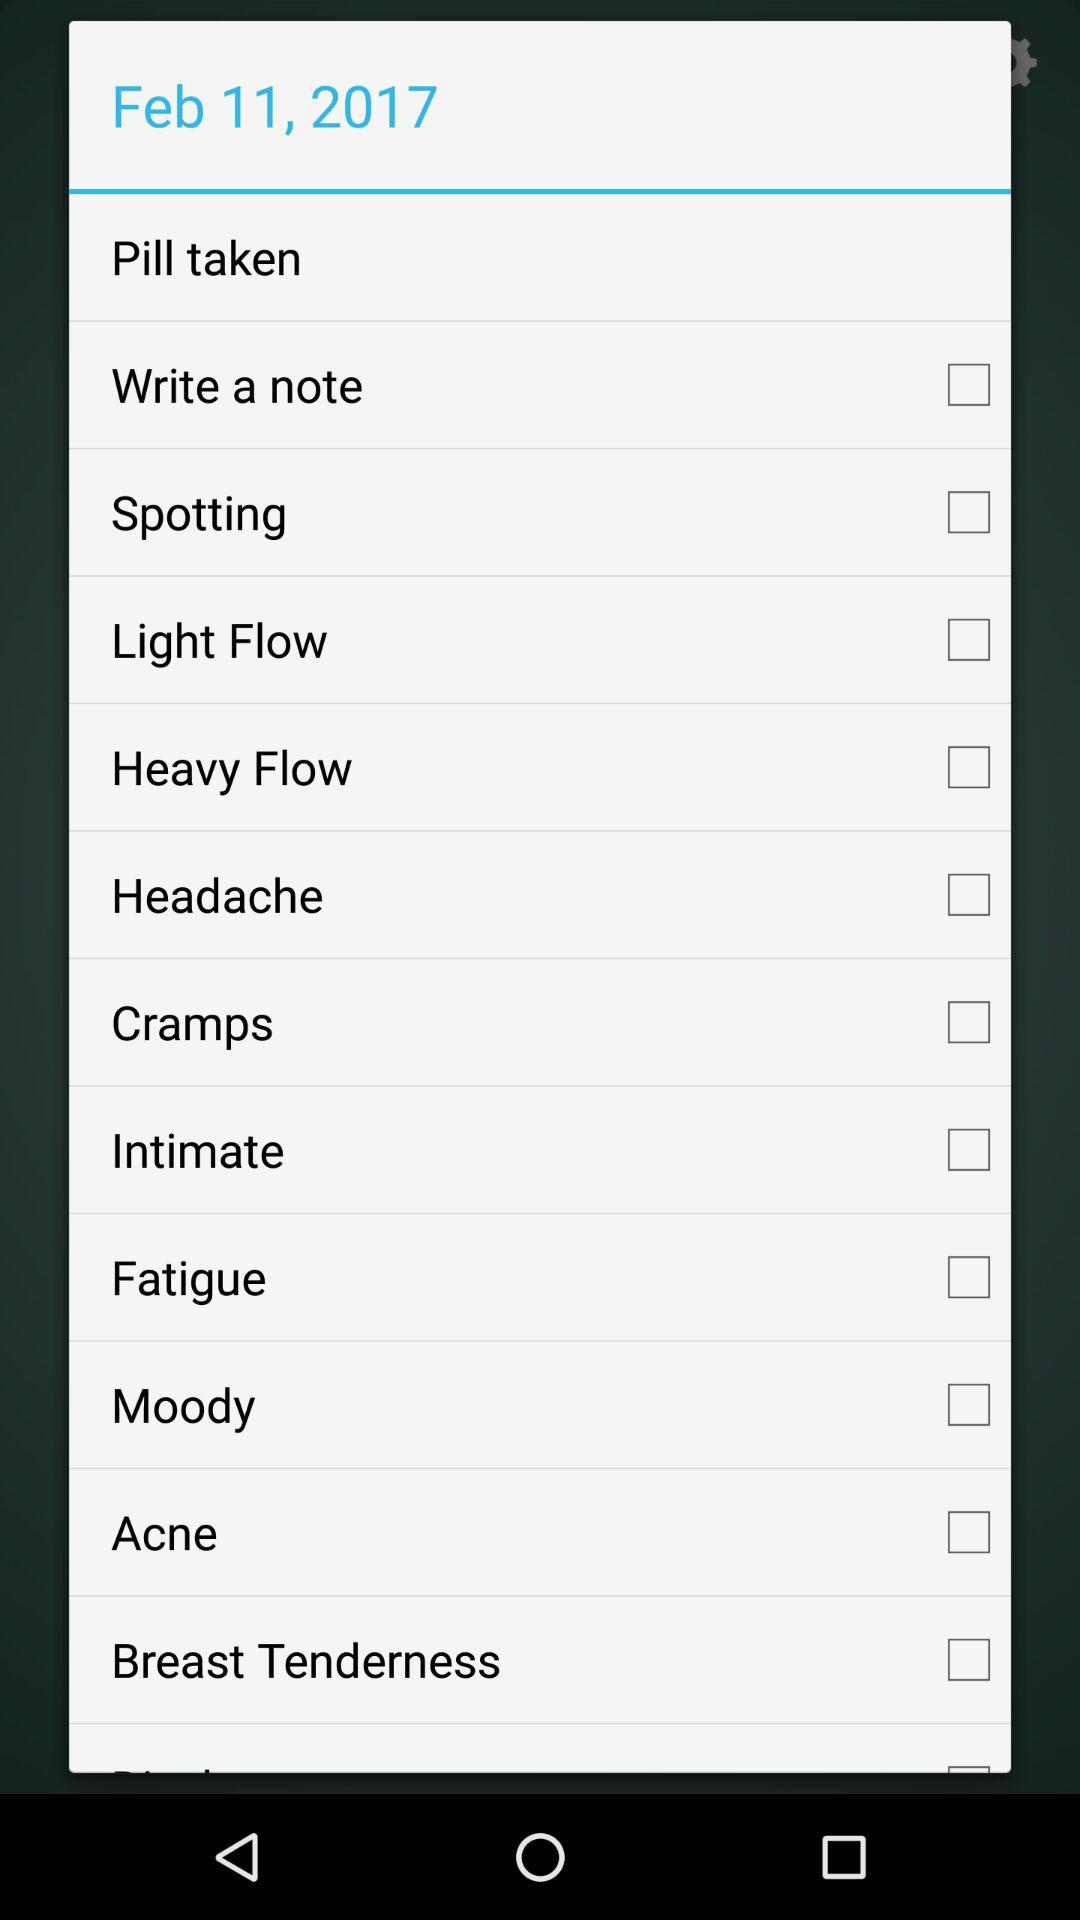What are the options available in the list? The options are "Pill taken", "Write a note", "Spotting", "Light Flow", "Heavy Flow", "Headache", "Cramps", "Intimate", "Fatigue", "Moody", "Acne" and "Breast Tenderness". 